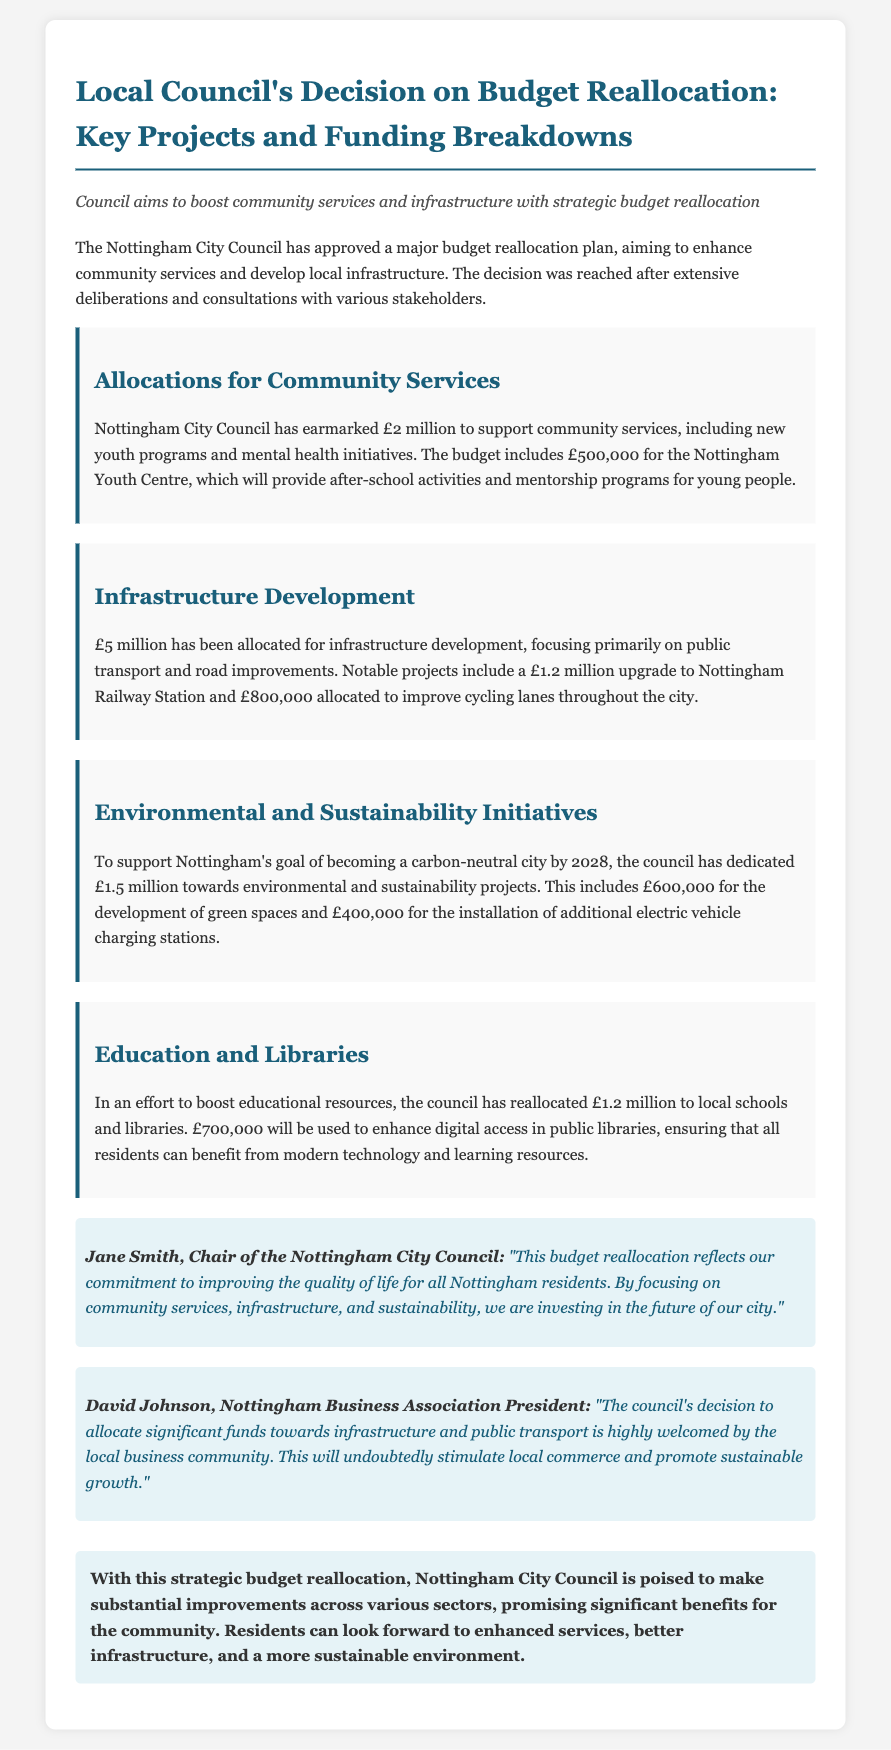What is the total amount allocated for community services? The total amount allocated for community services is specified within the section on Allocations for Community Services, which is £2 million.
Answer: £2 million How much funding is designated for the Nottingham Youth Centre? The document states that £500,000 is earmarked for the Nottingham Youth Centre specifically.
Answer: £500,000 What is the budget allocated for infrastructure development? The section on Infrastructure Development details an allocation of £5 million for this purpose.
Answer: £5 million Which project involves a £1.2 million upgrade? The document mentions that Nottingham Railway Station will receive a £1.2 million upgrade.
Answer: Nottingham Railway Station What is the goal year for Nottingham to become carbon-neutral? The document indicates that the city aims to achieve carbon neutrality by the year 2028.
Answer: 2028 How much funding is allocated for enhancing digital access in public libraries? The document specifies that £700,000 will be allocated for this enhancement in public libraries.
Answer: £700,000 Who is the Chair of the Nottingham City Council? The document identifies Jane Smith as the Chair of the Nottingham City Council.
Answer: Jane Smith What is the purpose of the £1.5 million dedicated to environmental and sustainability projects? The document explains that this funding supports Nottingham's goal of becoming a carbon-neutral city.
Answer: Carbon-neutral city What is the overall focus of the budget reallocation according to the press release? The press release highlights the focus on improving community services, infrastructure, and sustainability as the key areas of reallocation.
Answer: Community services, infrastructure, and sustainability 